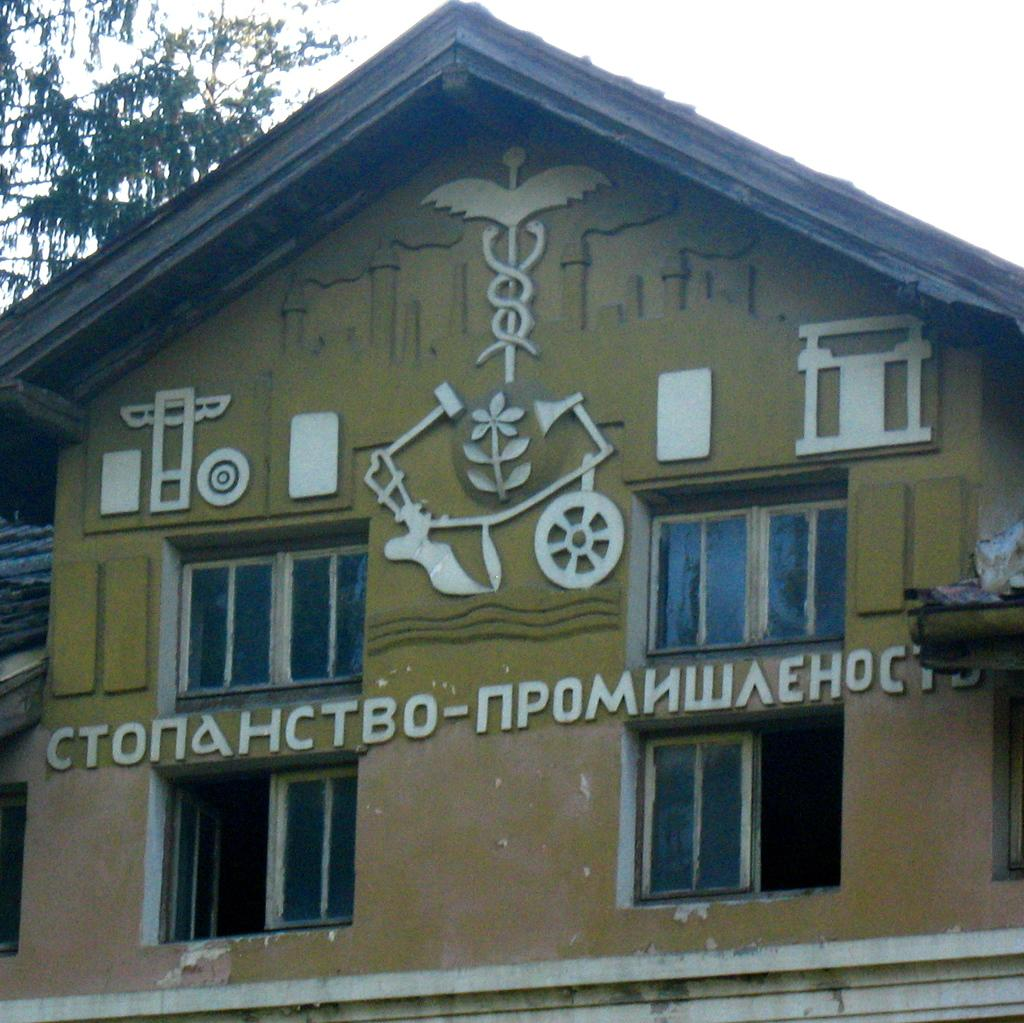What type of structure is in the picture? There is a house in the picture. How many windows can be seen on the house? The house has many windows. What is visible at the top of the picture? The sky is visible at the top of the picture. What type of vegetation is in the top left corner of the picture? There are trees in the top left corner of the picture. What color is the yarn used to knit the statement on the pig in the picture? There is no yarn, statement, or pig present in the picture. 